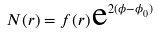<formula> <loc_0><loc_0><loc_500><loc_500>N ( r ) = f ( r ) \, \text {e} ^ { 2 ( \phi - \phi _ { 0 } ) }</formula> 